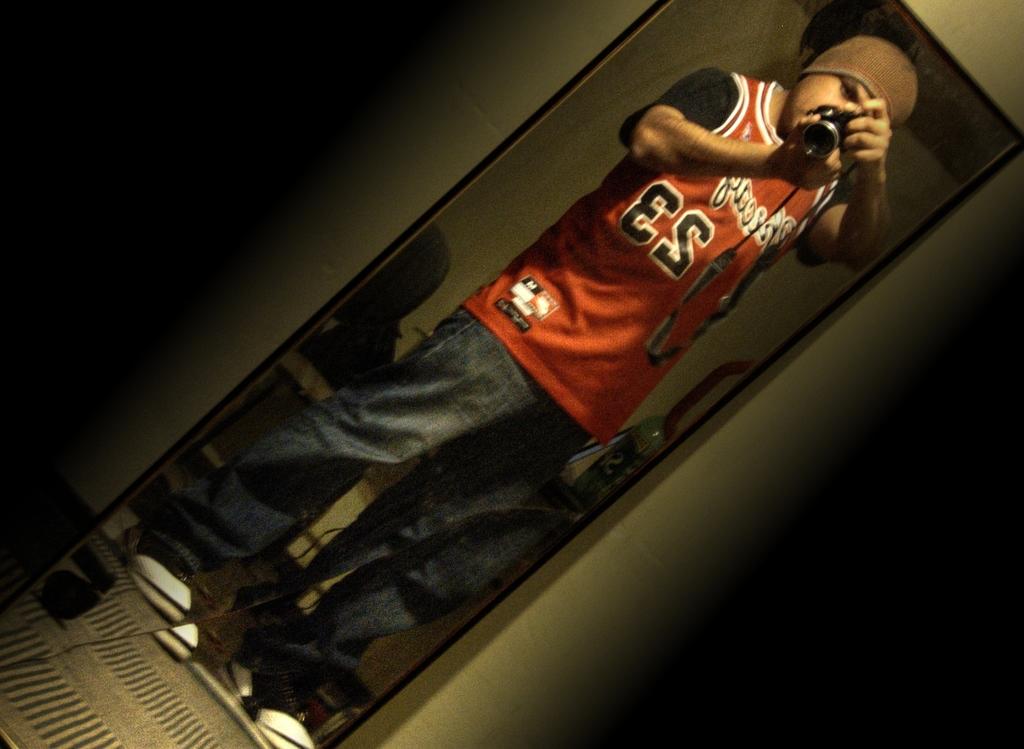Which team is this jersey of?
Ensure brevity in your answer.  Unanswerable. 